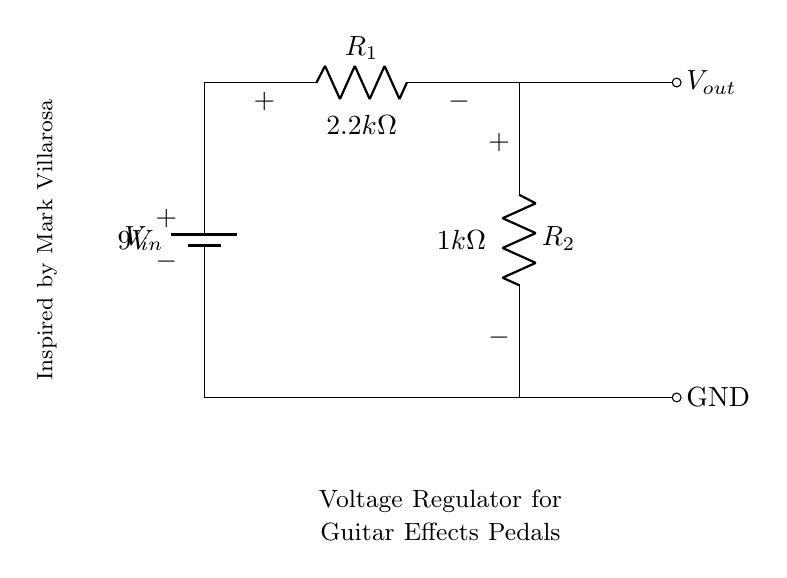What is the input voltage of the circuit? The input voltage is indicated as 9V, which is labeled on the battery in the circuit diagram.
Answer: 9V What are the resistance values of R1 and R2? The resistance values are labeled on the resistors in the circuit: R1 is 2.2kΩ and R2 is 1kΩ.
Answer: 2.2kΩ and 1kΩ What is the purpose of the voltage divider in this circuit? The voltage divider reduces the input voltage to a lower output voltage suitable for powering effects pedals. The circuit diagram demonstrates this configuration where the two resistors divide the voltage.
Answer: To reduce voltage What is the output voltage (Vout) supplied by this voltage divider? The output voltage can be calculated using the voltage divider formula: Vout = Vin * (R2 / (R1 + R2)). Substituting the values: Vout = 9V * (1kΩ / (2.2kΩ + 1kΩ)) = 2.73V, or approximately 2.7V.
Answer: 2.73V Which component is used to provide power in this circuit? The component that provides power is the battery, which is indicated at the top of the circuit diagram. It supplies the initial voltage of 9V.
Answer: Battery How does changing R1 affect the output voltage? Increasing R1 increases the total resistance in the voltage divider, which results in a lower output voltage as the ratio of R2 to the total resistance decreases. Conversely, decreasing R1 decreases the total resistance, increasing Vout.
Answer: Inversely proportional What inspired the design of this voltage regulator circuit? The design is inspired by Mark Villarosa, as noted in the circuit diagram. This shows the influence of this individual on the circuit's concept or structure.
Answer: Mark Villarosa 